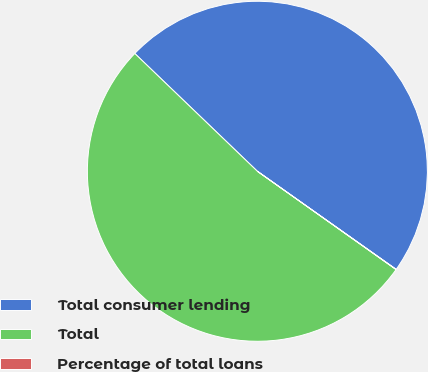Convert chart. <chart><loc_0><loc_0><loc_500><loc_500><pie_chart><fcel>Total consumer lending<fcel>Total<fcel>Percentage of total loans<nl><fcel>47.61%<fcel>52.37%<fcel>0.02%<nl></chart> 